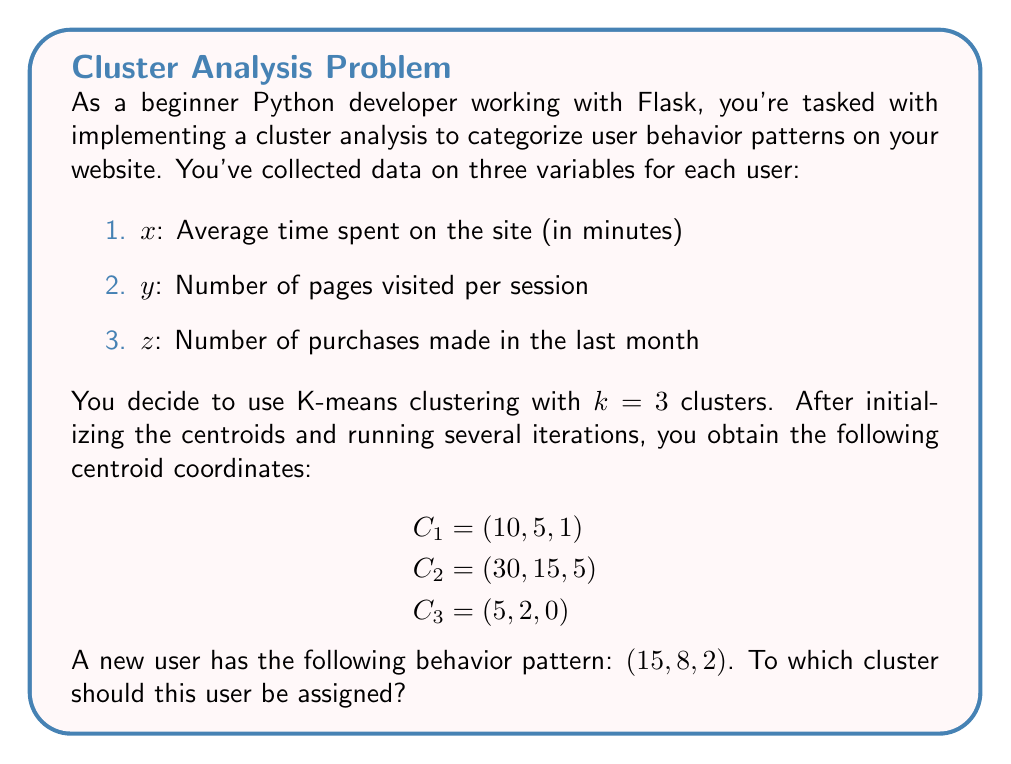Can you answer this question? To determine which cluster the new user should be assigned to, we need to calculate the Euclidean distance between the user's data point and each centroid. The cluster with the smallest distance will be the one to which the user is assigned.

Let's go through this step-by-step:

1. The Euclidean distance in 3D space is given by the formula:
   $$d = \sqrt{(x_2 - x_1)^2 + (y_2 - y_1)^2 + (z_2 - z_1)^2}$$

2. Calculate the distance to C1 (10, 5, 1):
   $$d_1 = \sqrt{(15 - 10)^2 + (8 - 5)^2 + (2 - 1)^2}$$
   $$d_1 = \sqrt{25 + 9 + 1} = \sqrt{35} \approx 5.92$$

3. Calculate the distance to C2 (30, 15, 5):
   $$d_2 = \sqrt{(15 - 30)^2 + (8 - 15)^2 + (2 - 5)^2}$$
   $$d_2 = \sqrt{225 + 49 + 9} = \sqrt{283} \approx 16.82$$

4. Calculate the distance to C3 (5, 2, 0):
   $$d_3 = \sqrt{(15 - 5)^2 + (8 - 2)^2 + (2 - 0)^2}$$
   $$d_3 = \sqrt{100 + 36 + 4} = \sqrt{140} \approx 11.83$$

5. Compare the distances:
   $d_1 \approx 5.92$
   $d_2 \approx 16.82$
   $d_3 \approx 11.83$

The smallest distance is $d_1$, which corresponds to cluster C1.
Answer: Cluster C1 